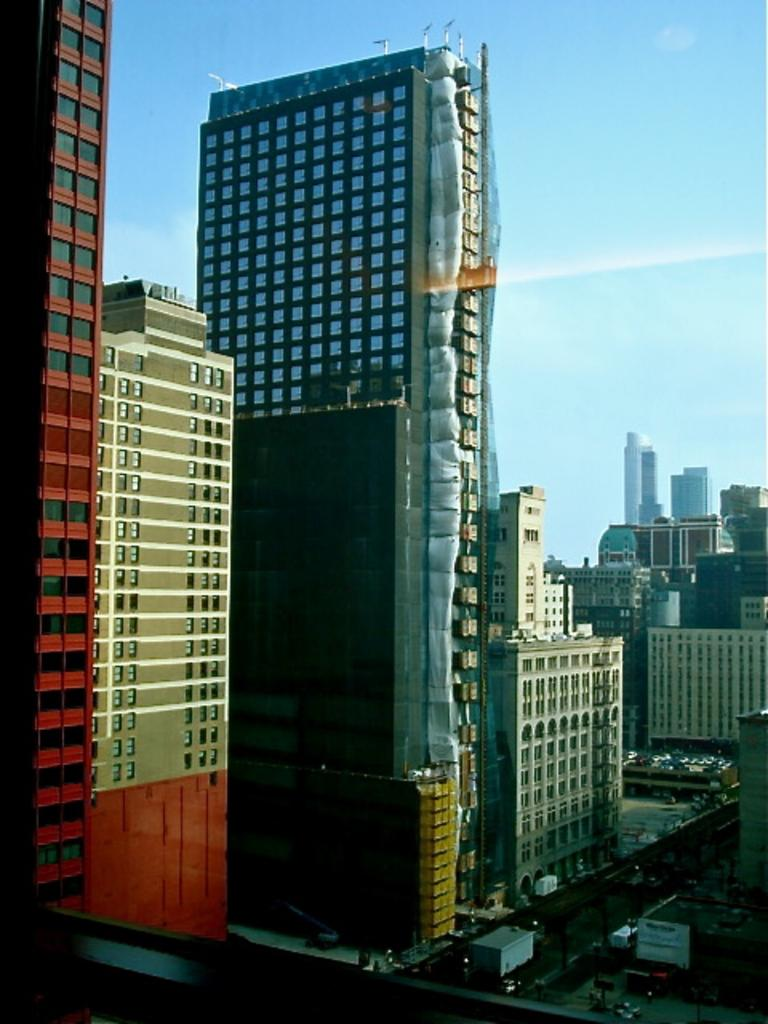What type of structures can be seen in the image? There are tall buildings in the image. What is located between the buildings? There is a road between the buildings. What can be seen on the road? There are vehicles on the road. How many centimeters of pickle can be seen on the road in the image? There is no pickle present on the road in the image. What type of jam is being spread on the buildings in the image? There is no jam present on the buildings in the image. 